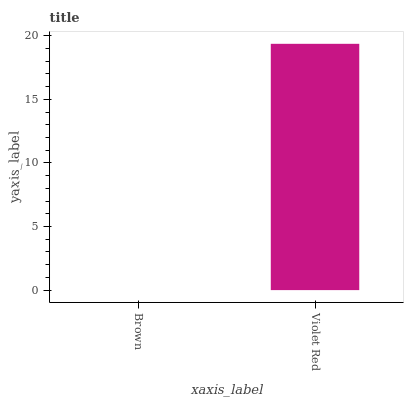Is Brown the minimum?
Answer yes or no. Yes. Is Violet Red the maximum?
Answer yes or no. Yes. Is Violet Red the minimum?
Answer yes or no. No. Is Violet Red greater than Brown?
Answer yes or no. Yes. Is Brown less than Violet Red?
Answer yes or no. Yes. Is Brown greater than Violet Red?
Answer yes or no. No. Is Violet Red less than Brown?
Answer yes or no. No. Is Violet Red the high median?
Answer yes or no. Yes. Is Brown the low median?
Answer yes or no. Yes. Is Brown the high median?
Answer yes or no. No. Is Violet Red the low median?
Answer yes or no. No. 